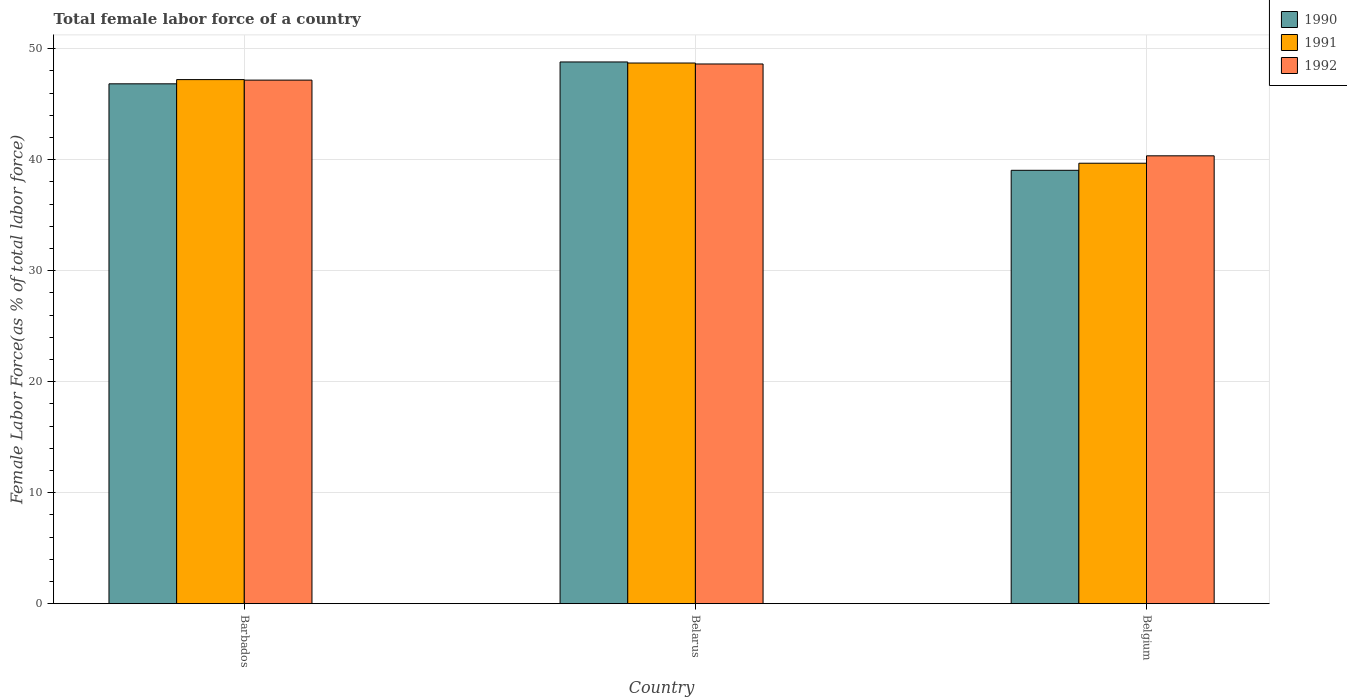How many groups of bars are there?
Offer a terse response. 3. How many bars are there on the 1st tick from the left?
Ensure brevity in your answer.  3. How many bars are there on the 3rd tick from the right?
Give a very brief answer. 3. What is the label of the 2nd group of bars from the left?
Provide a short and direct response. Belarus. What is the percentage of female labor force in 1991 in Barbados?
Provide a succinct answer. 47.21. Across all countries, what is the maximum percentage of female labor force in 1991?
Ensure brevity in your answer.  48.7. Across all countries, what is the minimum percentage of female labor force in 1991?
Your answer should be compact. 39.68. In which country was the percentage of female labor force in 1992 maximum?
Ensure brevity in your answer.  Belarus. In which country was the percentage of female labor force in 1992 minimum?
Provide a succinct answer. Belgium. What is the total percentage of female labor force in 1992 in the graph?
Offer a very short reply. 136.12. What is the difference between the percentage of female labor force in 1990 in Barbados and that in Belarus?
Offer a very short reply. -1.97. What is the difference between the percentage of female labor force in 1991 in Belarus and the percentage of female labor force in 1992 in Belgium?
Make the answer very short. 8.36. What is the average percentage of female labor force in 1991 per country?
Offer a terse response. 45.19. What is the difference between the percentage of female labor force of/in 1992 and percentage of female labor force of/in 1990 in Belarus?
Keep it short and to the point. -0.18. What is the ratio of the percentage of female labor force in 1990 in Barbados to that in Belarus?
Keep it short and to the point. 0.96. Is the percentage of female labor force in 1991 in Barbados less than that in Belarus?
Keep it short and to the point. Yes. Is the difference between the percentage of female labor force in 1992 in Belarus and Belgium greater than the difference between the percentage of female labor force in 1990 in Belarus and Belgium?
Provide a short and direct response. No. What is the difference between the highest and the second highest percentage of female labor force in 1992?
Your answer should be very brief. 8.27. What is the difference between the highest and the lowest percentage of female labor force in 1992?
Your answer should be compact. 8.27. In how many countries, is the percentage of female labor force in 1992 greater than the average percentage of female labor force in 1992 taken over all countries?
Offer a terse response. 2. Is the sum of the percentage of female labor force in 1990 in Belarus and Belgium greater than the maximum percentage of female labor force in 1991 across all countries?
Ensure brevity in your answer.  Yes. What does the 2nd bar from the left in Belgium represents?
Give a very brief answer. 1991. What does the 2nd bar from the right in Barbados represents?
Your response must be concise. 1991. Is it the case that in every country, the sum of the percentage of female labor force in 1992 and percentage of female labor force in 1990 is greater than the percentage of female labor force in 1991?
Ensure brevity in your answer.  Yes. Are all the bars in the graph horizontal?
Your response must be concise. No. Does the graph contain any zero values?
Keep it short and to the point. No. Where does the legend appear in the graph?
Offer a terse response. Top right. What is the title of the graph?
Provide a short and direct response. Total female labor force of a country. What is the label or title of the X-axis?
Ensure brevity in your answer.  Country. What is the label or title of the Y-axis?
Your answer should be very brief. Female Labor Force(as % of total labor force). What is the Female Labor Force(as % of total labor force) in 1990 in Barbados?
Provide a short and direct response. 46.83. What is the Female Labor Force(as % of total labor force) in 1991 in Barbados?
Your response must be concise. 47.21. What is the Female Labor Force(as % of total labor force) in 1992 in Barbados?
Your answer should be compact. 47.16. What is the Female Labor Force(as % of total labor force) in 1990 in Belarus?
Your response must be concise. 48.8. What is the Female Labor Force(as % of total labor force) in 1991 in Belarus?
Offer a terse response. 48.7. What is the Female Labor Force(as % of total labor force) in 1992 in Belarus?
Make the answer very short. 48.61. What is the Female Labor Force(as % of total labor force) in 1990 in Belgium?
Your answer should be very brief. 39.04. What is the Female Labor Force(as % of total labor force) in 1991 in Belgium?
Offer a very short reply. 39.68. What is the Female Labor Force(as % of total labor force) in 1992 in Belgium?
Offer a very short reply. 40.34. Across all countries, what is the maximum Female Labor Force(as % of total labor force) of 1990?
Make the answer very short. 48.8. Across all countries, what is the maximum Female Labor Force(as % of total labor force) in 1991?
Provide a succinct answer. 48.7. Across all countries, what is the maximum Female Labor Force(as % of total labor force) of 1992?
Offer a terse response. 48.61. Across all countries, what is the minimum Female Labor Force(as % of total labor force) of 1990?
Offer a very short reply. 39.04. Across all countries, what is the minimum Female Labor Force(as % of total labor force) of 1991?
Your answer should be compact. 39.68. Across all countries, what is the minimum Female Labor Force(as % of total labor force) in 1992?
Provide a short and direct response. 40.34. What is the total Female Labor Force(as % of total labor force) of 1990 in the graph?
Your response must be concise. 134.66. What is the total Female Labor Force(as % of total labor force) of 1991 in the graph?
Give a very brief answer. 135.58. What is the total Female Labor Force(as % of total labor force) in 1992 in the graph?
Your response must be concise. 136.12. What is the difference between the Female Labor Force(as % of total labor force) of 1990 in Barbados and that in Belarus?
Provide a succinct answer. -1.97. What is the difference between the Female Labor Force(as % of total labor force) of 1991 in Barbados and that in Belarus?
Your answer should be very brief. -1.49. What is the difference between the Female Labor Force(as % of total labor force) of 1992 in Barbados and that in Belarus?
Keep it short and to the point. -1.45. What is the difference between the Female Labor Force(as % of total labor force) in 1990 in Barbados and that in Belgium?
Your response must be concise. 7.79. What is the difference between the Female Labor Force(as % of total labor force) in 1991 in Barbados and that in Belgium?
Offer a terse response. 7.53. What is the difference between the Female Labor Force(as % of total labor force) of 1992 in Barbados and that in Belgium?
Provide a short and direct response. 6.82. What is the difference between the Female Labor Force(as % of total labor force) in 1990 in Belarus and that in Belgium?
Your response must be concise. 9.76. What is the difference between the Female Labor Force(as % of total labor force) in 1991 in Belarus and that in Belgium?
Your response must be concise. 9.03. What is the difference between the Female Labor Force(as % of total labor force) of 1992 in Belarus and that in Belgium?
Your response must be concise. 8.27. What is the difference between the Female Labor Force(as % of total labor force) in 1990 in Barbados and the Female Labor Force(as % of total labor force) in 1991 in Belarus?
Offer a terse response. -1.87. What is the difference between the Female Labor Force(as % of total labor force) in 1990 in Barbados and the Female Labor Force(as % of total labor force) in 1992 in Belarus?
Ensure brevity in your answer.  -1.79. What is the difference between the Female Labor Force(as % of total labor force) in 1991 in Barbados and the Female Labor Force(as % of total labor force) in 1992 in Belarus?
Offer a terse response. -1.41. What is the difference between the Female Labor Force(as % of total labor force) of 1990 in Barbados and the Female Labor Force(as % of total labor force) of 1991 in Belgium?
Your answer should be very brief. 7.15. What is the difference between the Female Labor Force(as % of total labor force) of 1990 in Barbados and the Female Labor Force(as % of total labor force) of 1992 in Belgium?
Give a very brief answer. 6.49. What is the difference between the Female Labor Force(as % of total labor force) of 1991 in Barbados and the Female Labor Force(as % of total labor force) of 1992 in Belgium?
Make the answer very short. 6.87. What is the difference between the Female Labor Force(as % of total labor force) of 1990 in Belarus and the Female Labor Force(as % of total labor force) of 1991 in Belgium?
Your answer should be compact. 9.12. What is the difference between the Female Labor Force(as % of total labor force) of 1990 in Belarus and the Female Labor Force(as % of total labor force) of 1992 in Belgium?
Offer a very short reply. 8.46. What is the difference between the Female Labor Force(as % of total labor force) in 1991 in Belarus and the Female Labor Force(as % of total labor force) in 1992 in Belgium?
Your response must be concise. 8.36. What is the average Female Labor Force(as % of total labor force) of 1990 per country?
Provide a short and direct response. 44.89. What is the average Female Labor Force(as % of total labor force) in 1991 per country?
Your answer should be very brief. 45.19. What is the average Female Labor Force(as % of total labor force) of 1992 per country?
Provide a short and direct response. 45.37. What is the difference between the Female Labor Force(as % of total labor force) in 1990 and Female Labor Force(as % of total labor force) in 1991 in Barbados?
Keep it short and to the point. -0.38. What is the difference between the Female Labor Force(as % of total labor force) of 1990 and Female Labor Force(as % of total labor force) of 1992 in Barbados?
Give a very brief answer. -0.33. What is the difference between the Female Labor Force(as % of total labor force) in 1991 and Female Labor Force(as % of total labor force) in 1992 in Barbados?
Offer a terse response. 0.05. What is the difference between the Female Labor Force(as % of total labor force) of 1990 and Female Labor Force(as % of total labor force) of 1991 in Belarus?
Your response must be concise. 0.1. What is the difference between the Female Labor Force(as % of total labor force) in 1990 and Female Labor Force(as % of total labor force) in 1992 in Belarus?
Your answer should be very brief. 0.18. What is the difference between the Female Labor Force(as % of total labor force) of 1991 and Female Labor Force(as % of total labor force) of 1992 in Belarus?
Your response must be concise. 0.09. What is the difference between the Female Labor Force(as % of total labor force) in 1990 and Female Labor Force(as % of total labor force) in 1991 in Belgium?
Your response must be concise. -0.64. What is the difference between the Female Labor Force(as % of total labor force) of 1990 and Female Labor Force(as % of total labor force) of 1992 in Belgium?
Ensure brevity in your answer.  -1.3. What is the difference between the Female Labor Force(as % of total labor force) of 1991 and Female Labor Force(as % of total labor force) of 1992 in Belgium?
Give a very brief answer. -0.67. What is the ratio of the Female Labor Force(as % of total labor force) in 1990 in Barbados to that in Belarus?
Provide a succinct answer. 0.96. What is the ratio of the Female Labor Force(as % of total labor force) of 1991 in Barbados to that in Belarus?
Your answer should be compact. 0.97. What is the ratio of the Female Labor Force(as % of total labor force) in 1992 in Barbados to that in Belarus?
Make the answer very short. 0.97. What is the ratio of the Female Labor Force(as % of total labor force) of 1990 in Barbados to that in Belgium?
Provide a succinct answer. 1.2. What is the ratio of the Female Labor Force(as % of total labor force) in 1991 in Barbados to that in Belgium?
Provide a short and direct response. 1.19. What is the ratio of the Female Labor Force(as % of total labor force) in 1992 in Barbados to that in Belgium?
Provide a short and direct response. 1.17. What is the ratio of the Female Labor Force(as % of total labor force) of 1990 in Belarus to that in Belgium?
Give a very brief answer. 1.25. What is the ratio of the Female Labor Force(as % of total labor force) of 1991 in Belarus to that in Belgium?
Your answer should be very brief. 1.23. What is the ratio of the Female Labor Force(as % of total labor force) of 1992 in Belarus to that in Belgium?
Offer a terse response. 1.21. What is the difference between the highest and the second highest Female Labor Force(as % of total labor force) in 1990?
Provide a succinct answer. 1.97. What is the difference between the highest and the second highest Female Labor Force(as % of total labor force) in 1991?
Your answer should be very brief. 1.49. What is the difference between the highest and the second highest Female Labor Force(as % of total labor force) in 1992?
Your answer should be very brief. 1.45. What is the difference between the highest and the lowest Female Labor Force(as % of total labor force) in 1990?
Your answer should be compact. 9.76. What is the difference between the highest and the lowest Female Labor Force(as % of total labor force) in 1991?
Offer a terse response. 9.03. What is the difference between the highest and the lowest Female Labor Force(as % of total labor force) of 1992?
Give a very brief answer. 8.27. 